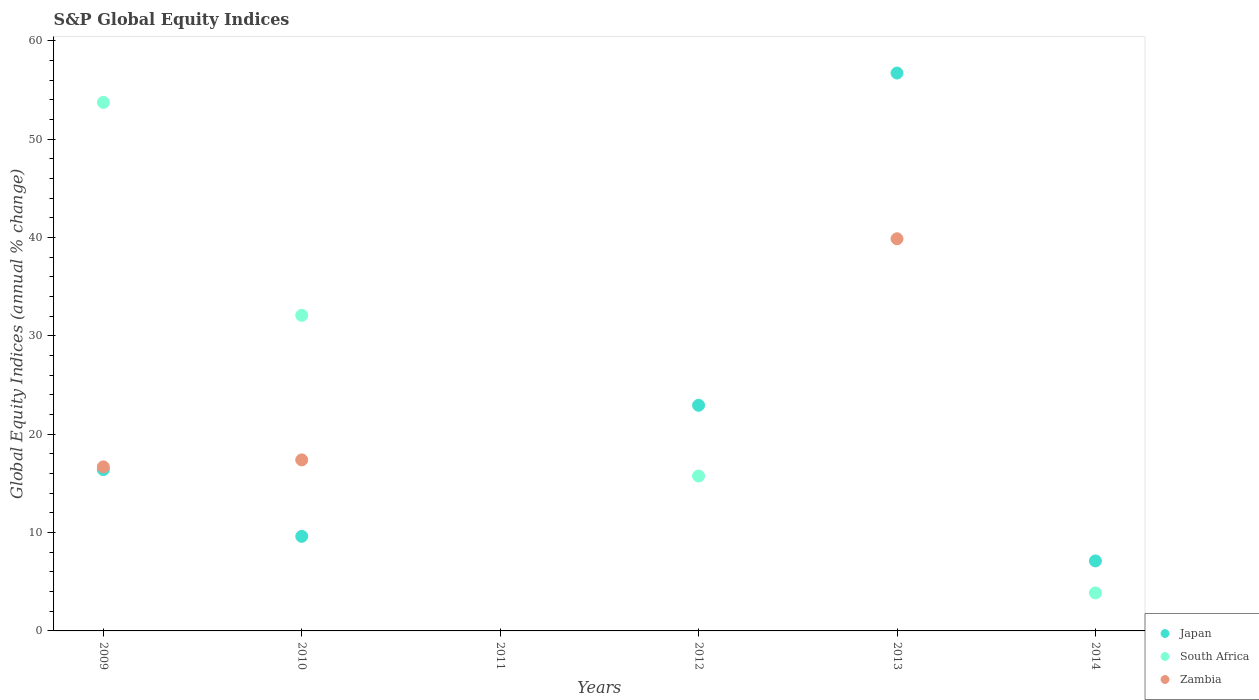How many different coloured dotlines are there?
Make the answer very short. 3. What is the global equity indices in Zambia in 2012?
Keep it short and to the point. 0. Across all years, what is the maximum global equity indices in Japan?
Provide a short and direct response. 56.72. Across all years, what is the minimum global equity indices in Japan?
Make the answer very short. 0. What is the total global equity indices in South Africa in the graph?
Offer a very short reply. 105.44. What is the difference between the global equity indices in Japan in 2010 and that in 2014?
Offer a terse response. 2.5. What is the difference between the global equity indices in Japan in 2013 and the global equity indices in South Africa in 2010?
Offer a terse response. 24.63. What is the average global equity indices in Japan per year?
Your response must be concise. 18.8. In the year 2013, what is the difference between the global equity indices in Zambia and global equity indices in Japan?
Your answer should be compact. -16.85. In how many years, is the global equity indices in Japan greater than 22 %?
Keep it short and to the point. 2. What is the ratio of the global equity indices in Japan in 2013 to that in 2014?
Give a very brief answer. 7.97. What is the difference between the highest and the second highest global equity indices in Zambia?
Ensure brevity in your answer.  22.48. What is the difference between the highest and the lowest global equity indices in Zambia?
Offer a terse response. 39.87. Is it the case that in every year, the sum of the global equity indices in Japan and global equity indices in Zambia  is greater than the global equity indices in South Africa?
Offer a terse response. No. Is the global equity indices in Japan strictly less than the global equity indices in Zambia over the years?
Give a very brief answer. No. How many dotlines are there?
Provide a short and direct response. 3. How many years are there in the graph?
Your answer should be very brief. 6. What is the difference between two consecutive major ticks on the Y-axis?
Provide a succinct answer. 10. Does the graph contain any zero values?
Provide a succinct answer. Yes. Where does the legend appear in the graph?
Provide a short and direct response. Bottom right. How many legend labels are there?
Your answer should be compact. 3. What is the title of the graph?
Your answer should be compact. S&P Global Equity Indices. Does "Heavily indebted poor countries" appear as one of the legend labels in the graph?
Your response must be concise. No. What is the label or title of the Y-axis?
Offer a very short reply. Global Equity Indices (annual % change). What is the Global Equity Indices (annual % change) of Japan in 2009?
Provide a succinct answer. 16.4. What is the Global Equity Indices (annual % change) of South Africa in 2009?
Give a very brief answer. 53.74. What is the Global Equity Indices (annual % change) in Zambia in 2009?
Ensure brevity in your answer.  16.68. What is the Global Equity Indices (annual % change) in Japan in 2010?
Your response must be concise. 9.61. What is the Global Equity Indices (annual % change) of South Africa in 2010?
Keep it short and to the point. 32.09. What is the Global Equity Indices (annual % change) in Zambia in 2010?
Ensure brevity in your answer.  17.39. What is the Global Equity Indices (annual % change) in Japan in 2012?
Your response must be concise. 22.94. What is the Global Equity Indices (annual % change) of South Africa in 2012?
Provide a succinct answer. 15.75. What is the Global Equity Indices (annual % change) in Japan in 2013?
Offer a very short reply. 56.72. What is the Global Equity Indices (annual % change) in Zambia in 2013?
Provide a succinct answer. 39.87. What is the Global Equity Indices (annual % change) of Japan in 2014?
Offer a terse response. 7.12. What is the Global Equity Indices (annual % change) in South Africa in 2014?
Your answer should be compact. 3.86. Across all years, what is the maximum Global Equity Indices (annual % change) of Japan?
Your answer should be compact. 56.72. Across all years, what is the maximum Global Equity Indices (annual % change) in South Africa?
Your answer should be very brief. 53.74. Across all years, what is the maximum Global Equity Indices (annual % change) of Zambia?
Offer a very short reply. 39.87. Across all years, what is the minimum Global Equity Indices (annual % change) in Zambia?
Your response must be concise. 0. What is the total Global Equity Indices (annual % change) in Japan in the graph?
Your answer should be very brief. 112.79. What is the total Global Equity Indices (annual % change) of South Africa in the graph?
Your response must be concise. 105.44. What is the total Global Equity Indices (annual % change) in Zambia in the graph?
Give a very brief answer. 73.93. What is the difference between the Global Equity Indices (annual % change) in Japan in 2009 and that in 2010?
Provide a short and direct response. 6.78. What is the difference between the Global Equity Indices (annual % change) of South Africa in 2009 and that in 2010?
Provide a succinct answer. 21.65. What is the difference between the Global Equity Indices (annual % change) of Zambia in 2009 and that in 2010?
Make the answer very short. -0.71. What is the difference between the Global Equity Indices (annual % change) in Japan in 2009 and that in 2012?
Offer a terse response. -6.54. What is the difference between the Global Equity Indices (annual % change) in South Africa in 2009 and that in 2012?
Make the answer very short. 37.99. What is the difference between the Global Equity Indices (annual % change) of Japan in 2009 and that in 2013?
Give a very brief answer. -40.32. What is the difference between the Global Equity Indices (annual % change) in Zambia in 2009 and that in 2013?
Give a very brief answer. -23.19. What is the difference between the Global Equity Indices (annual % change) in Japan in 2009 and that in 2014?
Offer a terse response. 9.28. What is the difference between the Global Equity Indices (annual % change) of South Africa in 2009 and that in 2014?
Ensure brevity in your answer.  49.87. What is the difference between the Global Equity Indices (annual % change) in Japan in 2010 and that in 2012?
Your answer should be very brief. -13.33. What is the difference between the Global Equity Indices (annual % change) in South Africa in 2010 and that in 2012?
Offer a very short reply. 16.34. What is the difference between the Global Equity Indices (annual % change) in Japan in 2010 and that in 2013?
Your response must be concise. -47.11. What is the difference between the Global Equity Indices (annual % change) in Zambia in 2010 and that in 2013?
Keep it short and to the point. -22.48. What is the difference between the Global Equity Indices (annual % change) in Japan in 2010 and that in 2014?
Give a very brief answer. 2.5. What is the difference between the Global Equity Indices (annual % change) in South Africa in 2010 and that in 2014?
Give a very brief answer. 28.22. What is the difference between the Global Equity Indices (annual % change) in Japan in 2012 and that in 2013?
Give a very brief answer. -33.78. What is the difference between the Global Equity Indices (annual % change) in Japan in 2012 and that in 2014?
Give a very brief answer. 15.82. What is the difference between the Global Equity Indices (annual % change) of South Africa in 2012 and that in 2014?
Your answer should be compact. 11.88. What is the difference between the Global Equity Indices (annual % change) in Japan in 2013 and that in 2014?
Your answer should be compact. 49.6. What is the difference between the Global Equity Indices (annual % change) in Japan in 2009 and the Global Equity Indices (annual % change) in South Africa in 2010?
Your response must be concise. -15.69. What is the difference between the Global Equity Indices (annual % change) in Japan in 2009 and the Global Equity Indices (annual % change) in Zambia in 2010?
Your answer should be very brief. -0.99. What is the difference between the Global Equity Indices (annual % change) in South Africa in 2009 and the Global Equity Indices (annual % change) in Zambia in 2010?
Give a very brief answer. 36.35. What is the difference between the Global Equity Indices (annual % change) of Japan in 2009 and the Global Equity Indices (annual % change) of South Africa in 2012?
Ensure brevity in your answer.  0.65. What is the difference between the Global Equity Indices (annual % change) in Japan in 2009 and the Global Equity Indices (annual % change) in Zambia in 2013?
Give a very brief answer. -23.47. What is the difference between the Global Equity Indices (annual % change) of South Africa in 2009 and the Global Equity Indices (annual % change) of Zambia in 2013?
Provide a succinct answer. 13.87. What is the difference between the Global Equity Indices (annual % change) in Japan in 2009 and the Global Equity Indices (annual % change) in South Africa in 2014?
Provide a succinct answer. 12.53. What is the difference between the Global Equity Indices (annual % change) in Japan in 2010 and the Global Equity Indices (annual % change) in South Africa in 2012?
Your answer should be very brief. -6.13. What is the difference between the Global Equity Indices (annual % change) of Japan in 2010 and the Global Equity Indices (annual % change) of Zambia in 2013?
Your answer should be very brief. -30.25. What is the difference between the Global Equity Indices (annual % change) of South Africa in 2010 and the Global Equity Indices (annual % change) of Zambia in 2013?
Provide a succinct answer. -7.78. What is the difference between the Global Equity Indices (annual % change) in Japan in 2010 and the Global Equity Indices (annual % change) in South Africa in 2014?
Offer a terse response. 5.75. What is the difference between the Global Equity Indices (annual % change) in Japan in 2012 and the Global Equity Indices (annual % change) in Zambia in 2013?
Keep it short and to the point. -16.93. What is the difference between the Global Equity Indices (annual % change) of South Africa in 2012 and the Global Equity Indices (annual % change) of Zambia in 2013?
Offer a terse response. -24.12. What is the difference between the Global Equity Indices (annual % change) of Japan in 2012 and the Global Equity Indices (annual % change) of South Africa in 2014?
Your answer should be compact. 19.08. What is the difference between the Global Equity Indices (annual % change) of Japan in 2013 and the Global Equity Indices (annual % change) of South Africa in 2014?
Offer a very short reply. 52.86. What is the average Global Equity Indices (annual % change) of Japan per year?
Provide a short and direct response. 18.8. What is the average Global Equity Indices (annual % change) of South Africa per year?
Give a very brief answer. 17.57. What is the average Global Equity Indices (annual % change) in Zambia per year?
Your response must be concise. 12.32. In the year 2009, what is the difference between the Global Equity Indices (annual % change) of Japan and Global Equity Indices (annual % change) of South Africa?
Ensure brevity in your answer.  -37.34. In the year 2009, what is the difference between the Global Equity Indices (annual % change) in Japan and Global Equity Indices (annual % change) in Zambia?
Keep it short and to the point. -0.28. In the year 2009, what is the difference between the Global Equity Indices (annual % change) of South Africa and Global Equity Indices (annual % change) of Zambia?
Your answer should be compact. 37.06. In the year 2010, what is the difference between the Global Equity Indices (annual % change) in Japan and Global Equity Indices (annual % change) in South Africa?
Keep it short and to the point. -22.47. In the year 2010, what is the difference between the Global Equity Indices (annual % change) in Japan and Global Equity Indices (annual % change) in Zambia?
Keep it short and to the point. -7.77. In the year 2010, what is the difference between the Global Equity Indices (annual % change) in South Africa and Global Equity Indices (annual % change) in Zambia?
Provide a succinct answer. 14.7. In the year 2012, what is the difference between the Global Equity Indices (annual % change) in Japan and Global Equity Indices (annual % change) in South Africa?
Your answer should be compact. 7.19. In the year 2013, what is the difference between the Global Equity Indices (annual % change) of Japan and Global Equity Indices (annual % change) of Zambia?
Make the answer very short. 16.85. In the year 2014, what is the difference between the Global Equity Indices (annual % change) in Japan and Global Equity Indices (annual % change) in South Africa?
Your answer should be compact. 3.25. What is the ratio of the Global Equity Indices (annual % change) of Japan in 2009 to that in 2010?
Offer a very short reply. 1.71. What is the ratio of the Global Equity Indices (annual % change) in South Africa in 2009 to that in 2010?
Ensure brevity in your answer.  1.67. What is the ratio of the Global Equity Indices (annual % change) in Zambia in 2009 to that in 2010?
Your response must be concise. 0.96. What is the ratio of the Global Equity Indices (annual % change) of Japan in 2009 to that in 2012?
Your answer should be very brief. 0.71. What is the ratio of the Global Equity Indices (annual % change) of South Africa in 2009 to that in 2012?
Ensure brevity in your answer.  3.41. What is the ratio of the Global Equity Indices (annual % change) in Japan in 2009 to that in 2013?
Offer a very short reply. 0.29. What is the ratio of the Global Equity Indices (annual % change) of Zambia in 2009 to that in 2013?
Keep it short and to the point. 0.42. What is the ratio of the Global Equity Indices (annual % change) of Japan in 2009 to that in 2014?
Provide a short and direct response. 2.3. What is the ratio of the Global Equity Indices (annual % change) in South Africa in 2009 to that in 2014?
Provide a succinct answer. 13.91. What is the ratio of the Global Equity Indices (annual % change) of Japan in 2010 to that in 2012?
Offer a terse response. 0.42. What is the ratio of the Global Equity Indices (annual % change) in South Africa in 2010 to that in 2012?
Offer a terse response. 2.04. What is the ratio of the Global Equity Indices (annual % change) of Japan in 2010 to that in 2013?
Provide a short and direct response. 0.17. What is the ratio of the Global Equity Indices (annual % change) in Zambia in 2010 to that in 2013?
Ensure brevity in your answer.  0.44. What is the ratio of the Global Equity Indices (annual % change) of Japan in 2010 to that in 2014?
Provide a succinct answer. 1.35. What is the ratio of the Global Equity Indices (annual % change) in South Africa in 2010 to that in 2014?
Provide a succinct answer. 8.3. What is the ratio of the Global Equity Indices (annual % change) of Japan in 2012 to that in 2013?
Ensure brevity in your answer.  0.4. What is the ratio of the Global Equity Indices (annual % change) of Japan in 2012 to that in 2014?
Give a very brief answer. 3.22. What is the ratio of the Global Equity Indices (annual % change) in South Africa in 2012 to that in 2014?
Offer a very short reply. 4.08. What is the ratio of the Global Equity Indices (annual % change) of Japan in 2013 to that in 2014?
Provide a succinct answer. 7.97. What is the difference between the highest and the second highest Global Equity Indices (annual % change) in Japan?
Offer a terse response. 33.78. What is the difference between the highest and the second highest Global Equity Indices (annual % change) in South Africa?
Provide a succinct answer. 21.65. What is the difference between the highest and the second highest Global Equity Indices (annual % change) of Zambia?
Provide a succinct answer. 22.48. What is the difference between the highest and the lowest Global Equity Indices (annual % change) in Japan?
Keep it short and to the point. 56.72. What is the difference between the highest and the lowest Global Equity Indices (annual % change) of South Africa?
Ensure brevity in your answer.  53.74. What is the difference between the highest and the lowest Global Equity Indices (annual % change) of Zambia?
Make the answer very short. 39.87. 